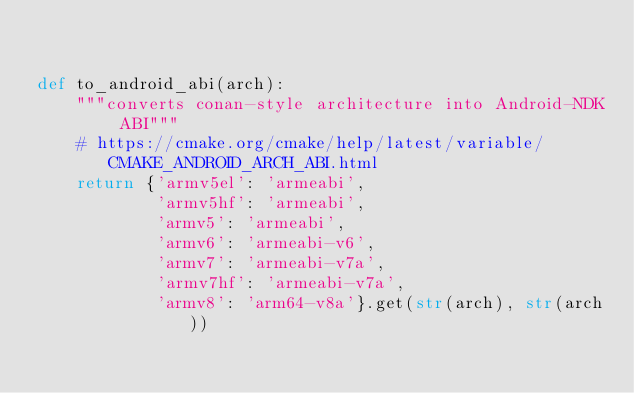<code> <loc_0><loc_0><loc_500><loc_500><_Python_>

def to_android_abi(arch):
    """converts conan-style architecture into Android-NDK ABI"""
    # https://cmake.org/cmake/help/latest/variable/CMAKE_ANDROID_ARCH_ABI.html
    return {'armv5el': 'armeabi',
            'armv5hf': 'armeabi',
            'armv5': 'armeabi',
            'armv6': 'armeabi-v6',
            'armv7': 'armeabi-v7a',
            'armv7hf': 'armeabi-v7a',
            'armv8': 'arm64-v8a'}.get(str(arch), str(arch))
</code> 